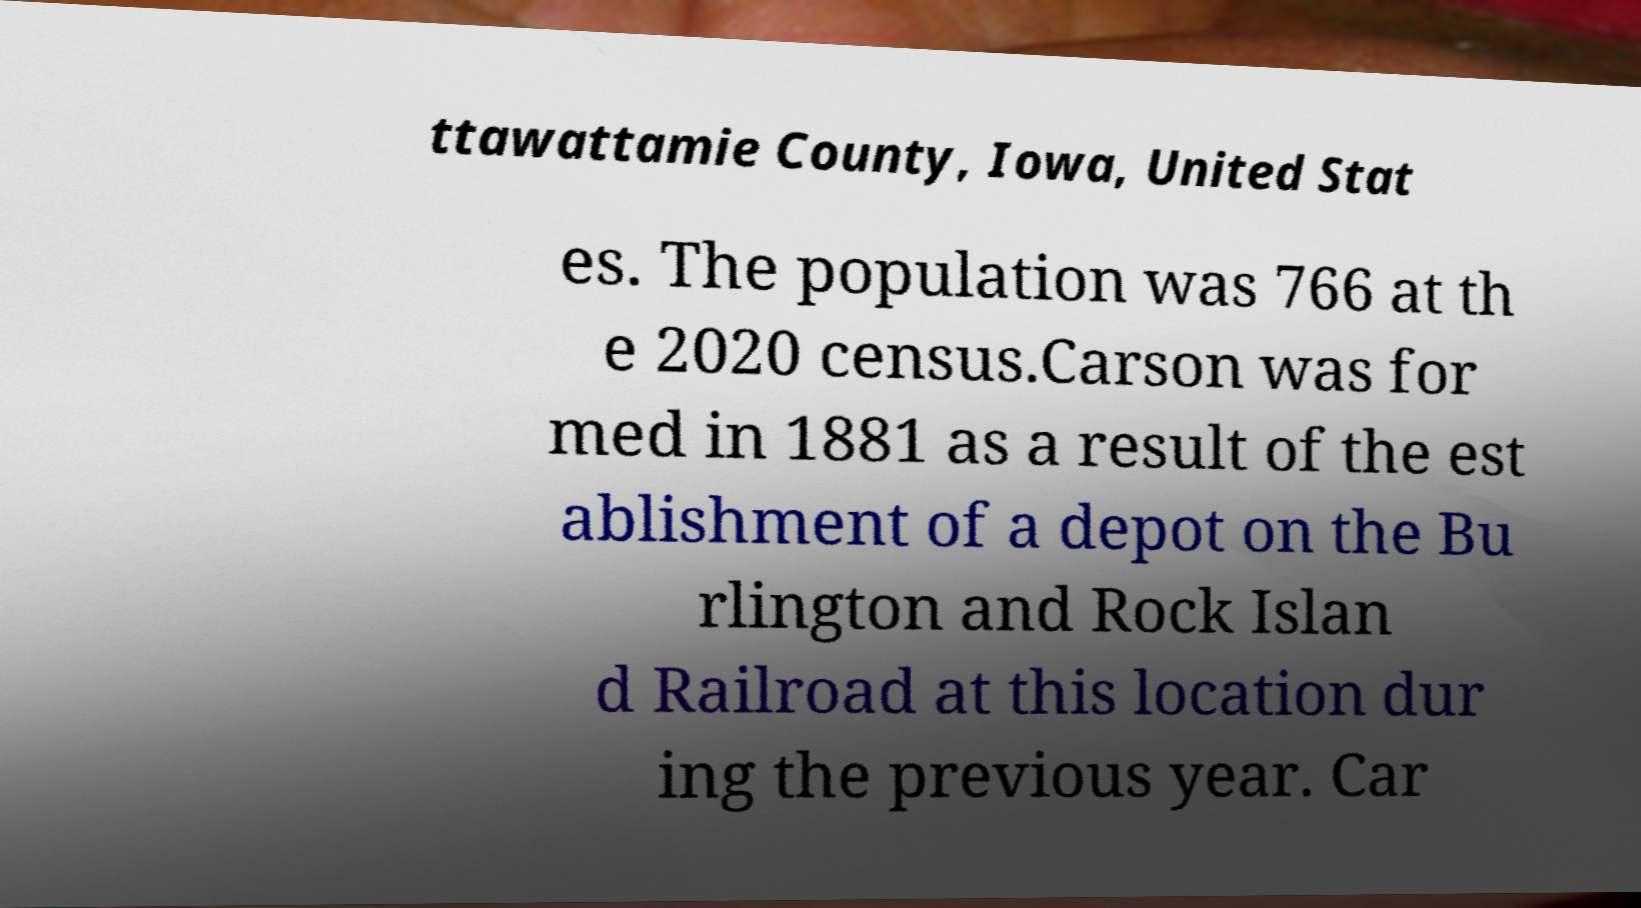Can you read and provide the text displayed in the image?This photo seems to have some interesting text. Can you extract and type it out for me? ttawattamie County, Iowa, United Stat es. The population was 766 at th e 2020 census.Carson was for med in 1881 as a result of the est ablishment of a depot on the Bu rlington and Rock Islan d Railroad at this location dur ing the previous year. Car 